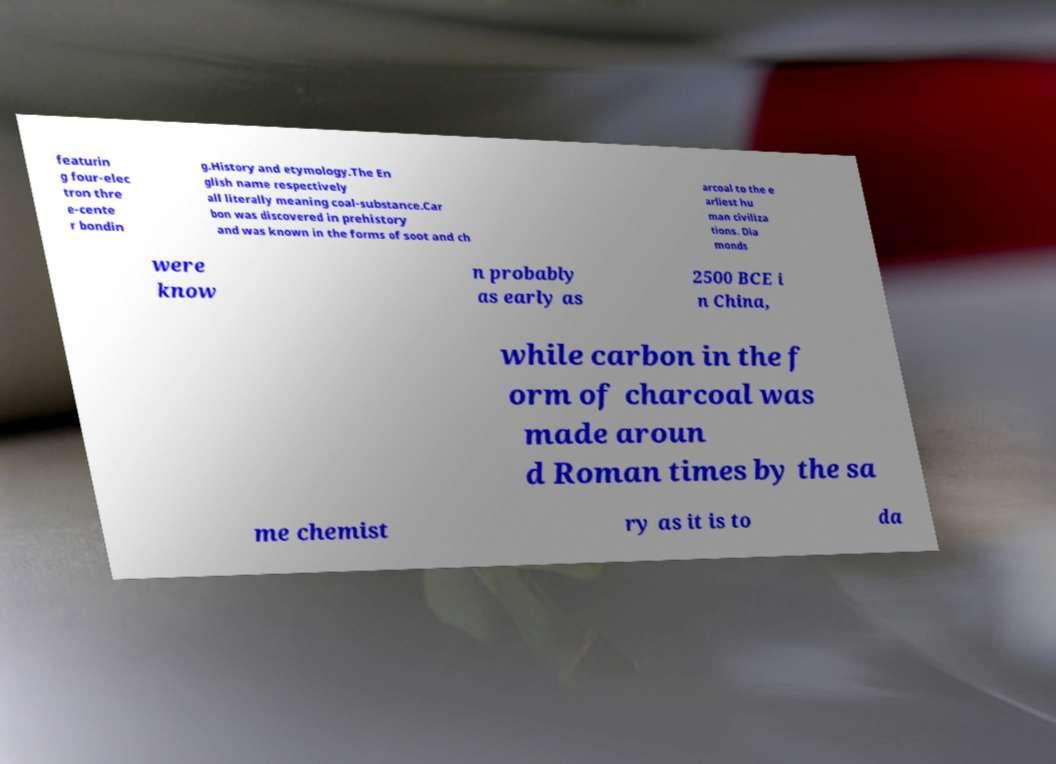Please read and relay the text visible in this image. What does it say? featurin g four-elec tron thre e-cente r bondin g.History and etymology.The En glish name respectively all literally meaning coal-substance.Car bon was discovered in prehistory and was known in the forms of soot and ch arcoal to the e arliest hu man civiliza tions. Dia monds were know n probably as early as 2500 BCE i n China, while carbon in the f orm of charcoal was made aroun d Roman times by the sa me chemist ry as it is to da 